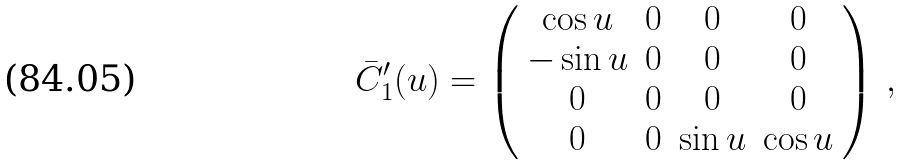Convert formula to latex. <formula><loc_0><loc_0><loc_500><loc_500>\bar { C } _ { 1 } ^ { \prime } ( u ) = \left ( \begin{array} { c c c c } \cos u & 0 & 0 & 0 \\ - \sin u & 0 & 0 & 0 \\ 0 & 0 & 0 & 0 \\ 0 & 0 & \sin u & \cos u \end{array} \right ) \, ,</formula> 